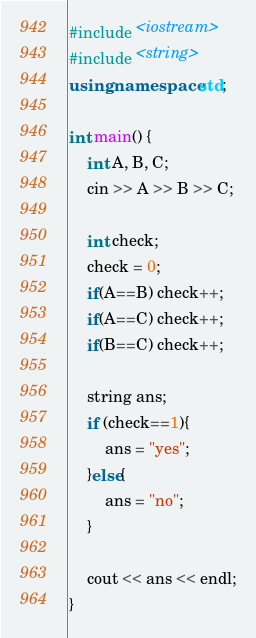Convert code to text. <code><loc_0><loc_0><loc_500><loc_500><_C++_>#include <iostream>
#include <string>
using namespace std;

int main() {
    int A, B, C;
    cin >> A >> B >> C;

    int check;
    check = 0;
    if(A==B) check++;
    if(A==C) check++;
    if(B==C) check++;

    string ans;
    if (check==1){
        ans = "yes";
    }else{
        ans = "no";
    }
    
    cout << ans << endl;
}</code> 